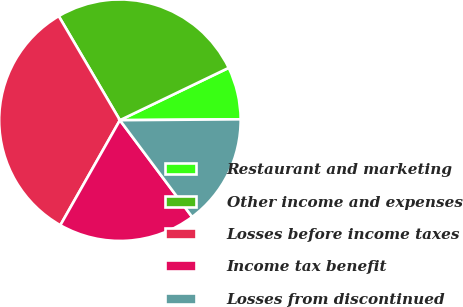<chart> <loc_0><loc_0><loc_500><loc_500><pie_chart><fcel>Restaurant and marketing<fcel>Other income and expenses<fcel>Losses before income taxes<fcel>Income tax benefit<fcel>Losses from discontinued<nl><fcel>7.02%<fcel>26.32%<fcel>33.33%<fcel>18.42%<fcel>14.91%<nl></chart> 